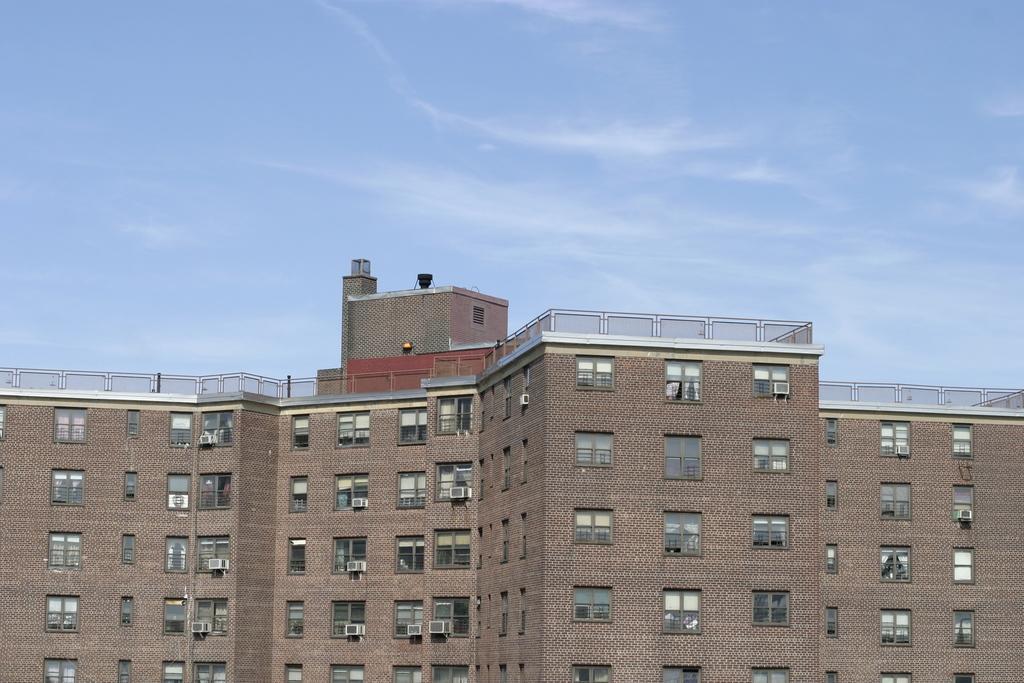Describe this image in one or two sentences. In this picture I can see there is a huge building and it has windows. It is a multi storied building and the sky is clear. 